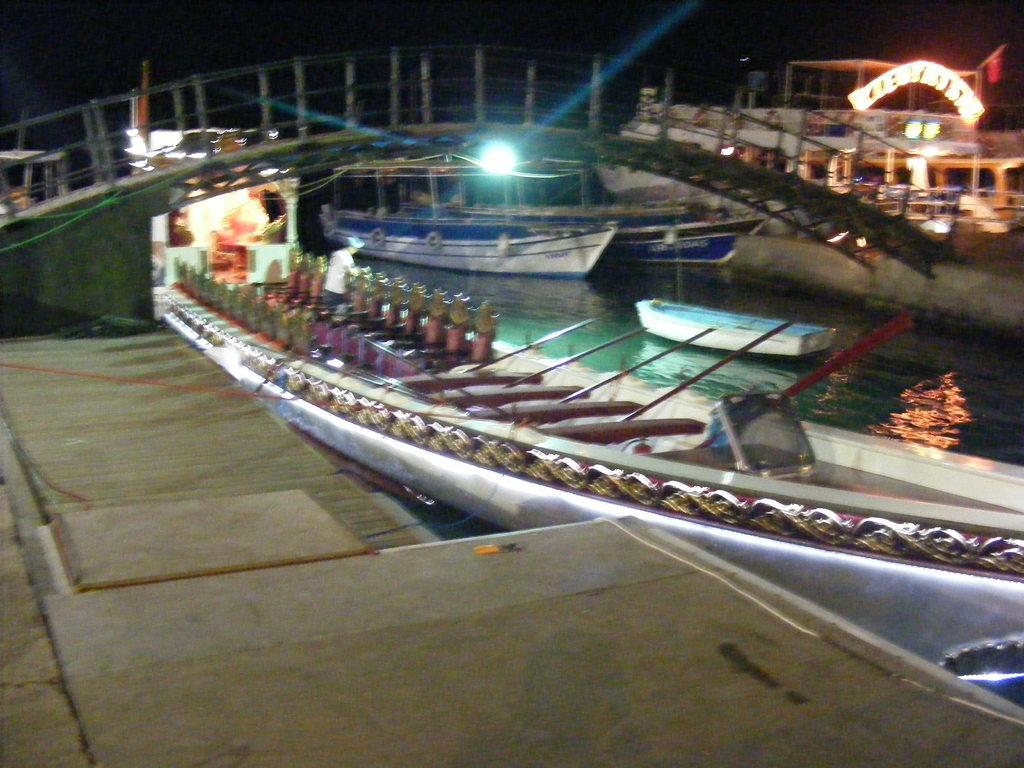What type of vehicles are in the image? There are boats in the image. What is the current state of the boats? The boats are parked. Where are the boats located in relation to the bridge? The boats are located under a bridge. How many geese can be seen swimming near the boats in the image? There are no geese present in the image; it only features boats parked under a bridge. 